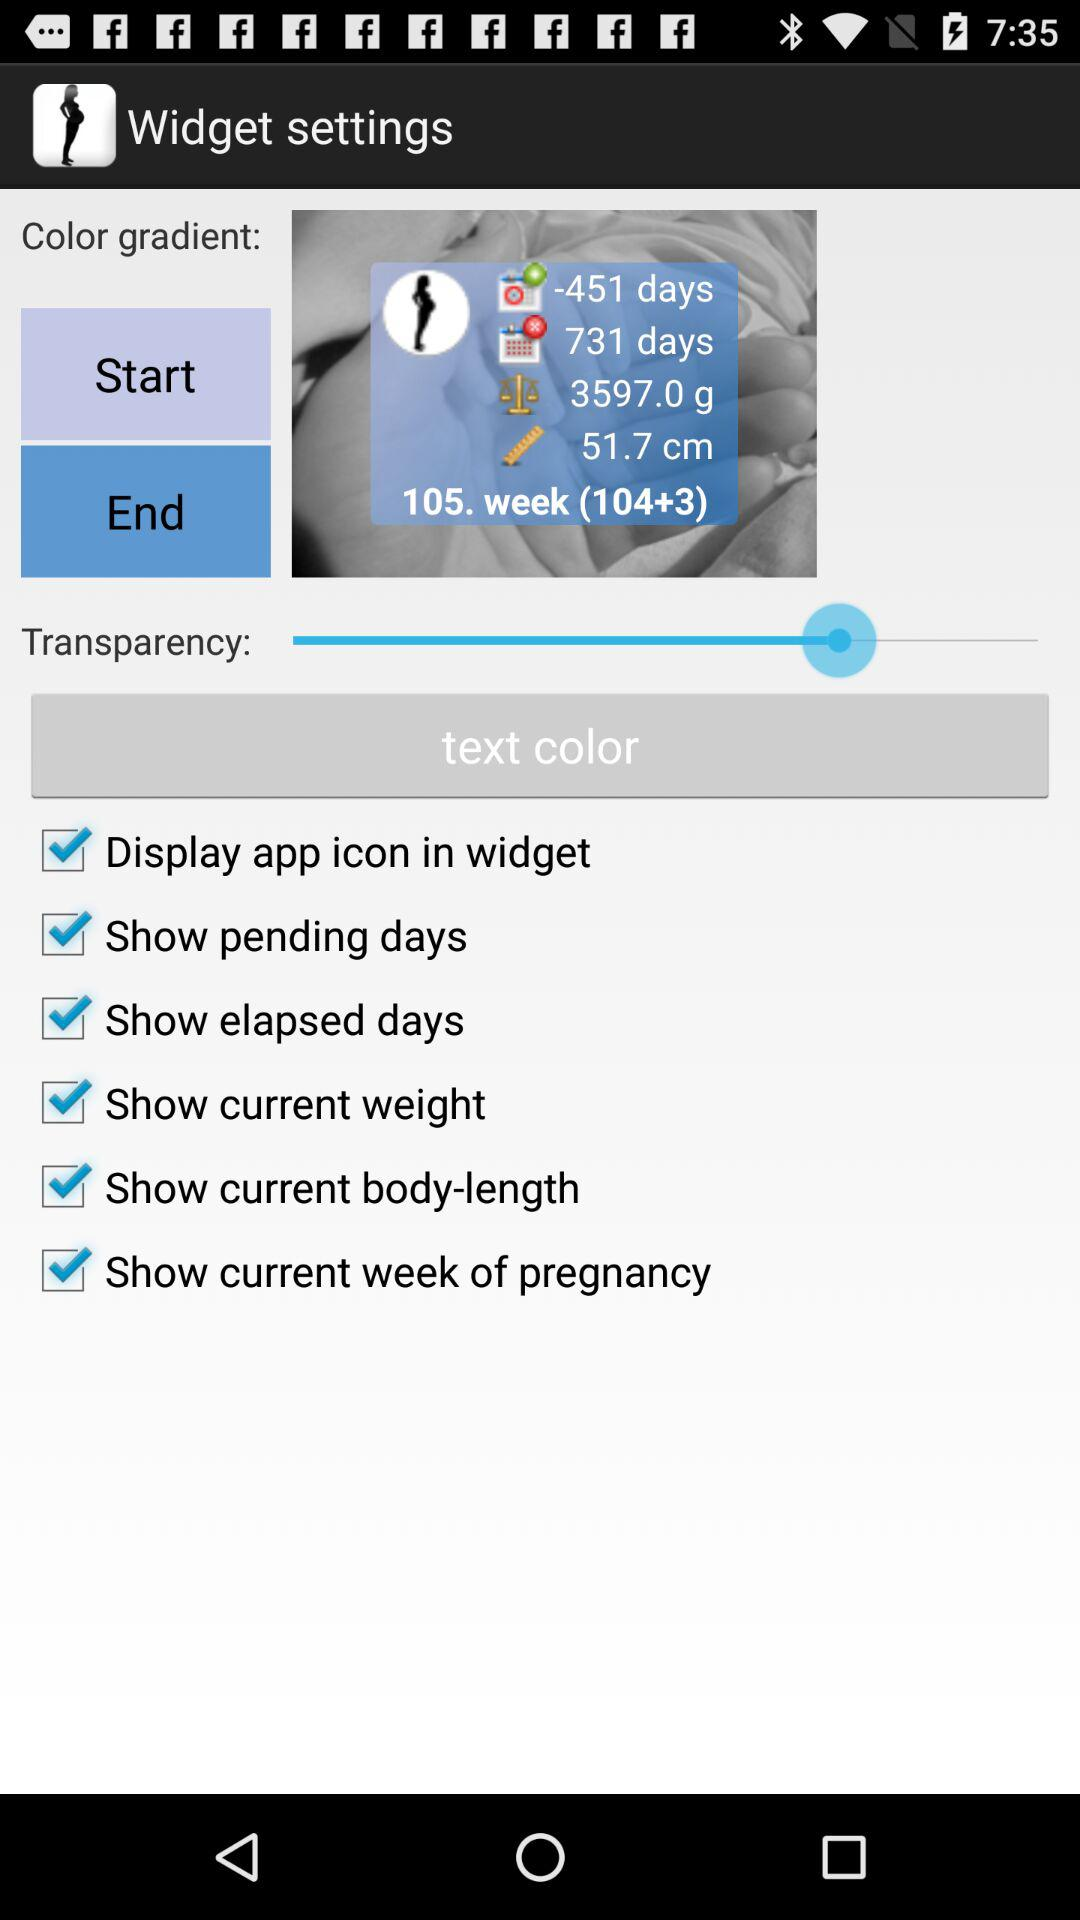What is the current length of the body?
When the provided information is insufficient, respond with <no answer>. <no answer> 